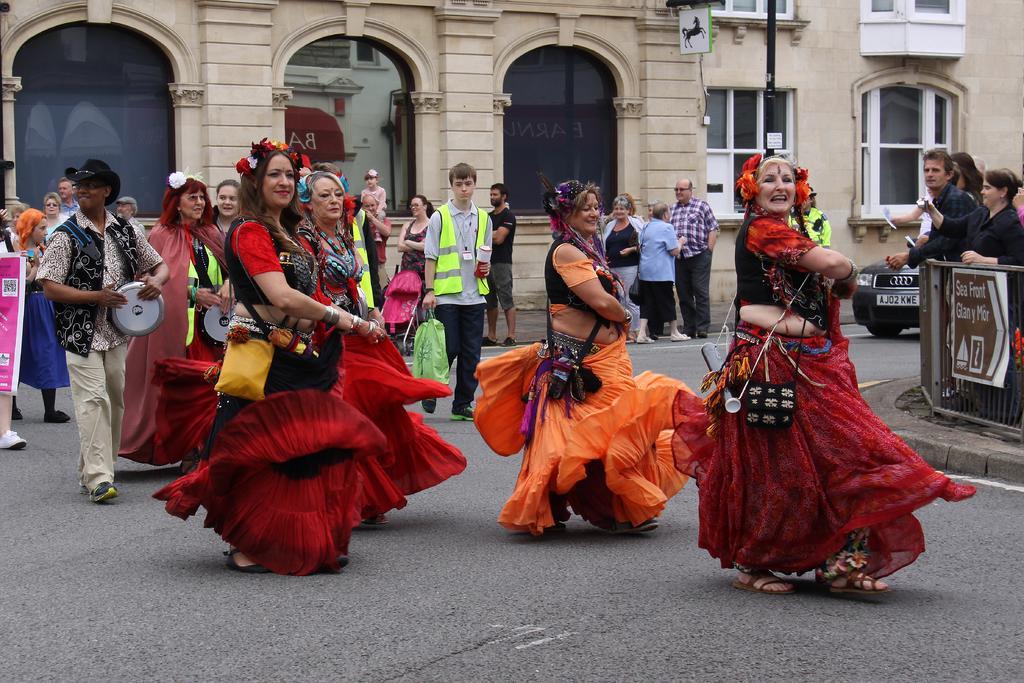Please provide a concise description of this image. In this image, I can see a group of dancing and few people standing on the road. On the right side of the image, this is a board, which is attached to the iron grilles. In the background, there are buildings with windows, pole and a car. On the left side of the image, I can see a man playing a musical instrument. 